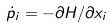Convert formula to latex. <formula><loc_0><loc_0><loc_500><loc_500>\dot { p } _ { i } = - \partial H / \partial x _ { i }</formula> 